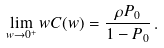<formula> <loc_0><loc_0><loc_500><loc_500>\lim _ { w \rightarrow 0 ^ { + } } w C ( w ) = \frac { \rho P _ { 0 } } { 1 - P _ { 0 } } \, .</formula> 